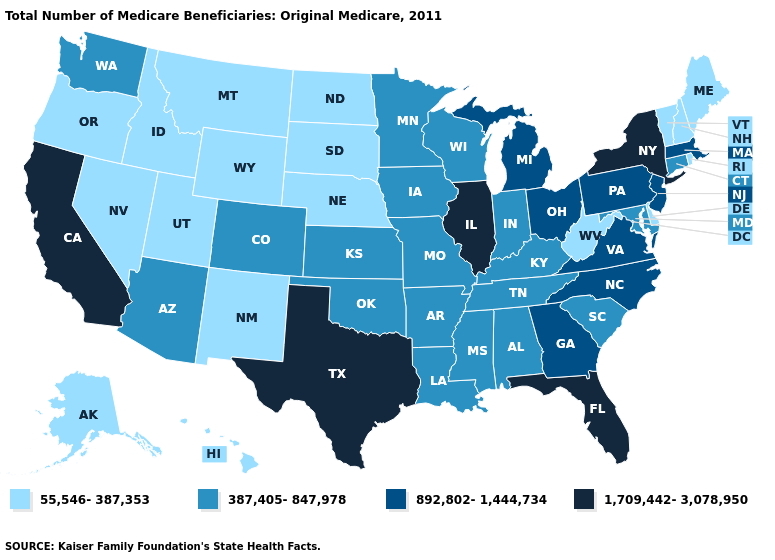Name the states that have a value in the range 387,405-847,978?
Be succinct. Alabama, Arizona, Arkansas, Colorado, Connecticut, Indiana, Iowa, Kansas, Kentucky, Louisiana, Maryland, Minnesota, Mississippi, Missouri, Oklahoma, South Carolina, Tennessee, Washington, Wisconsin. What is the lowest value in the USA?
Give a very brief answer. 55,546-387,353. Does Texas have the highest value in the USA?
Answer briefly. Yes. What is the value of Utah?
Concise answer only. 55,546-387,353. What is the value of Vermont?
Be succinct. 55,546-387,353. Does North Dakota have the lowest value in the USA?
Keep it brief. Yes. Name the states that have a value in the range 892,802-1,444,734?
Answer briefly. Georgia, Massachusetts, Michigan, New Jersey, North Carolina, Ohio, Pennsylvania, Virginia. Name the states that have a value in the range 55,546-387,353?
Concise answer only. Alaska, Delaware, Hawaii, Idaho, Maine, Montana, Nebraska, Nevada, New Hampshire, New Mexico, North Dakota, Oregon, Rhode Island, South Dakota, Utah, Vermont, West Virginia, Wyoming. What is the lowest value in the Northeast?
Concise answer only. 55,546-387,353. What is the value of Maine?
Be succinct. 55,546-387,353. Name the states that have a value in the range 892,802-1,444,734?
Quick response, please. Georgia, Massachusetts, Michigan, New Jersey, North Carolina, Ohio, Pennsylvania, Virginia. What is the value of South Dakota?
Keep it brief. 55,546-387,353. Does Illinois have the same value as California?
Quick response, please. Yes. 